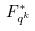Convert formula to latex. <formula><loc_0><loc_0><loc_500><loc_500>F _ { q ^ { k } } ^ { * }</formula> 